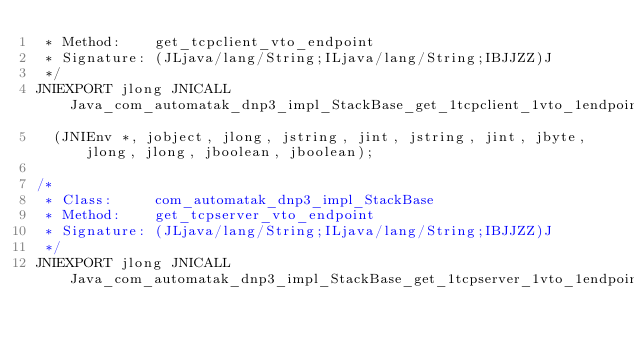<code> <loc_0><loc_0><loc_500><loc_500><_C_> * Method:    get_tcpclient_vto_endpoint
 * Signature: (JLjava/lang/String;ILjava/lang/String;IBJJZZ)J
 */
JNIEXPORT jlong JNICALL Java_com_automatak_dnp3_impl_StackBase_get_1tcpclient_1vto_1endpoint
  (JNIEnv *, jobject, jlong, jstring, jint, jstring, jint, jbyte, jlong, jlong, jboolean, jboolean);

/*
 * Class:     com_automatak_dnp3_impl_StackBase
 * Method:    get_tcpserver_vto_endpoint
 * Signature: (JLjava/lang/String;ILjava/lang/String;IBJJZZ)J
 */
JNIEXPORT jlong JNICALL Java_com_automatak_dnp3_impl_StackBase_get_1tcpserver_1vto_1endpoint</code> 